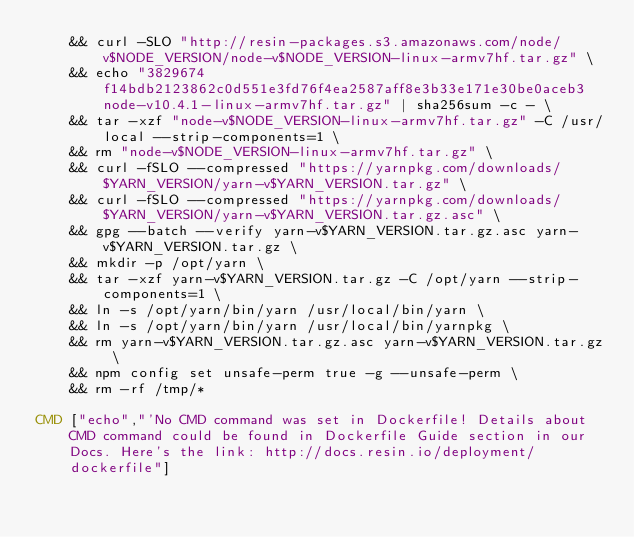<code> <loc_0><loc_0><loc_500><loc_500><_Dockerfile_>	&& curl -SLO "http://resin-packages.s3.amazonaws.com/node/v$NODE_VERSION/node-v$NODE_VERSION-linux-armv7hf.tar.gz" \
	&& echo "3829674f14bdb2123862c0d551e3fd76f4ea2587aff8e3b33e171e30be0aceb3  node-v10.4.1-linux-armv7hf.tar.gz" | sha256sum -c - \
	&& tar -xzf "node-v$NODE_VERSION-linux-armv7hf.tar.gz" -C /usr/local --strip-components=1 \
	&& rm "node-v$NODE_VERSION-linux-armv7hf.tar.gz" \
	&& curl -fSLO --compressed "https://yarnpkg.com/downloads/$YARN_VERSION/yarn-v$YARN_VERSION.tar.gz" \
	&& curl -fSLO --compressed "https://yarnpkg.com/downloads/$YARN_VERSION/yarn-v$YARN_VERSION.tar.gz.asc" \
	&& gpg --batch --verify yarn-v$YARN_VERSION.tar.gz.asc yarn-v$YARN_VERSION.tar.gz \
	&& mkdir -p /opt/yarn \
	&& tar -xzf yarn-v$YARN_VERSION.tar.gz -C /opt/yarn --strip-components=1 \
	&& ln -s /opt/yarn/bin/yarn /usr/local/bin/yarn \
	&& ln -s /opt/yarn/bin/yarn /usr/local/bin/yarnpkg \
	&& rm yarn-v$YARN_VERSION.tar.gz.asc yarn-v$YARN_VERSION.tar.gz \
	&& npm config set unsafe-perm true -g --unsafe-perm \
	&& rm -rf /tmp/*

CMD ["echo","'No CMD command was set in Dockerfile! Details about CMD command could be found in Dockerfile Guide section in our Docs. Here's the link: http://docs.resin.io/deployment/dockerfile"]
</code> 